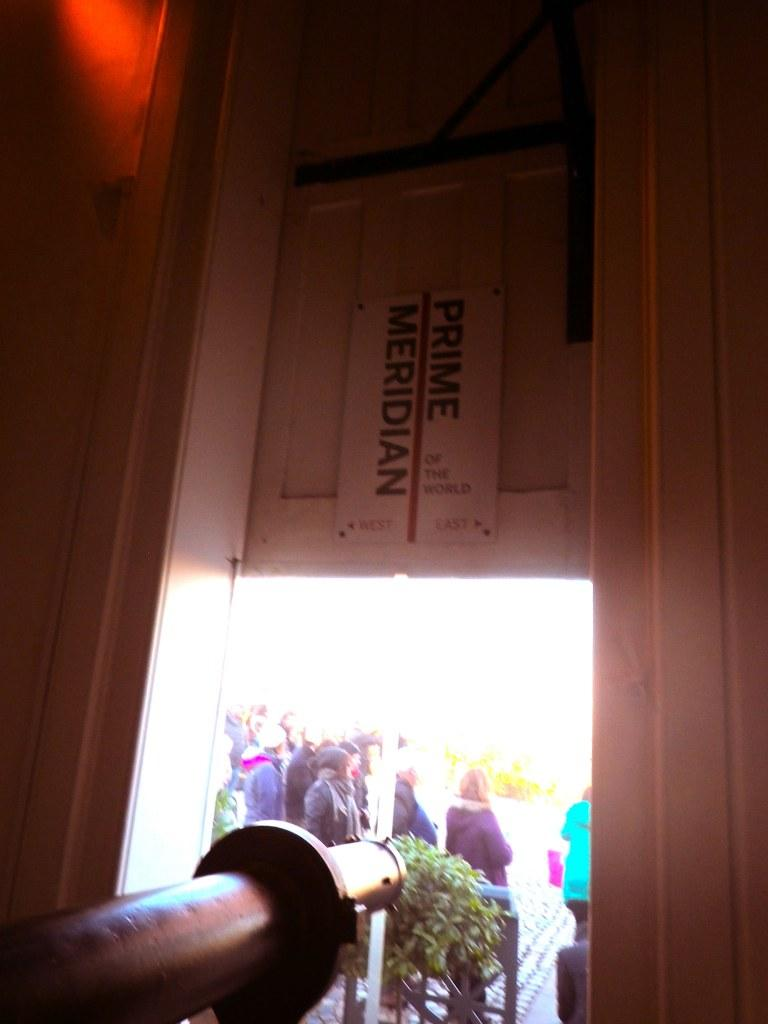What is one of the main objects in the image? There is a door in the image. What type of living organism can be seen in the image? There is a plant in the image. Are there any human beings present in the image? Yes, there are people present in the image. What type of farm animals can be seen in the image? There are no farm animals present in the image. What is the end result of the people's actions in the image? The image does not depict any specific actions or end results; it simply shows the presence of people, a door, and a plant. 